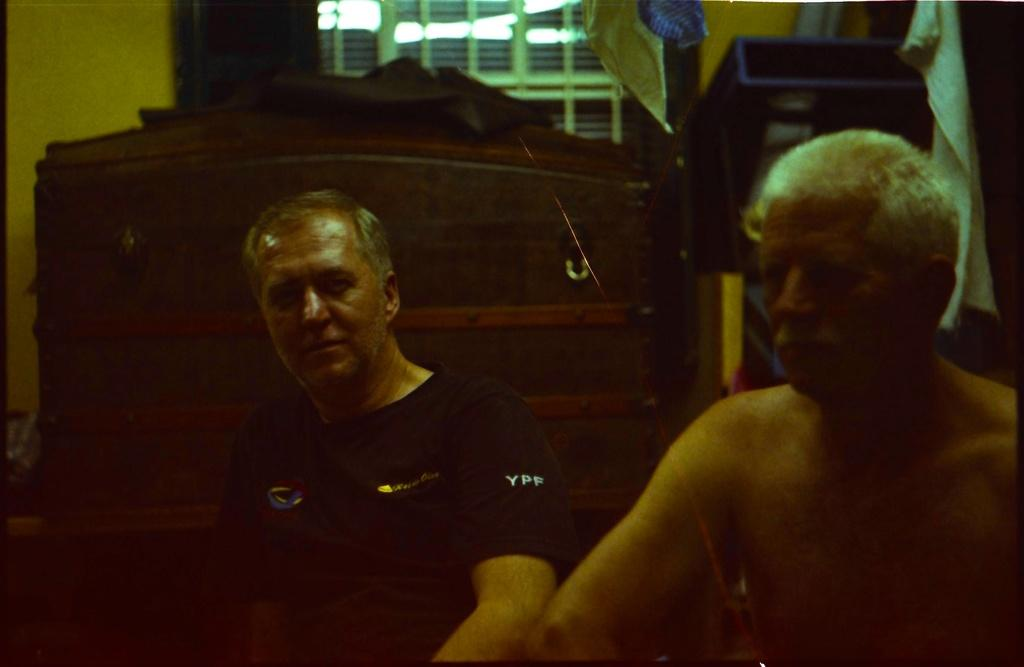How many people are in the image? There are two men in the image. What can be seen in the image besides the men? Clothes and windows are visible in the image. What language are the men speaking in the image? There is no information about the language being spoken in the image. Are there any cherries visible in the image? There are no cherries present in the image. 